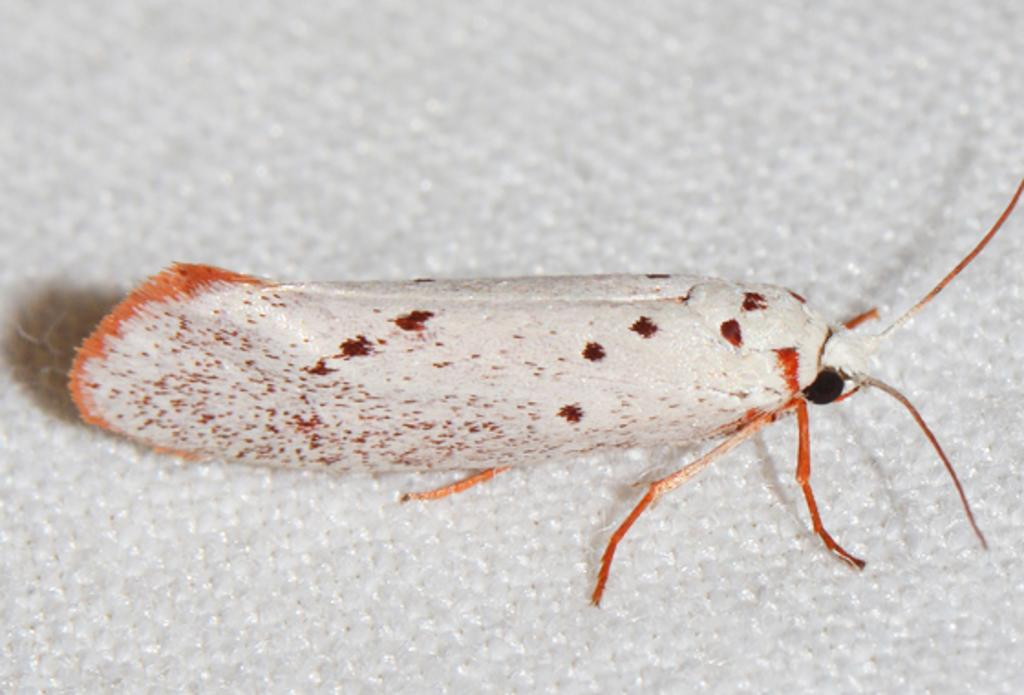What type of creature is present in the image? There is an insect in the image. What is the color of the surface where the insect is located? The insect is on a white color surface. Can you see the insect's self in the image? There is no indication of the insect having a self or self-awareness in the image. What phase of the moon is visible in the image? There is no moon visible in the image; it only features an insect on a white surface. 